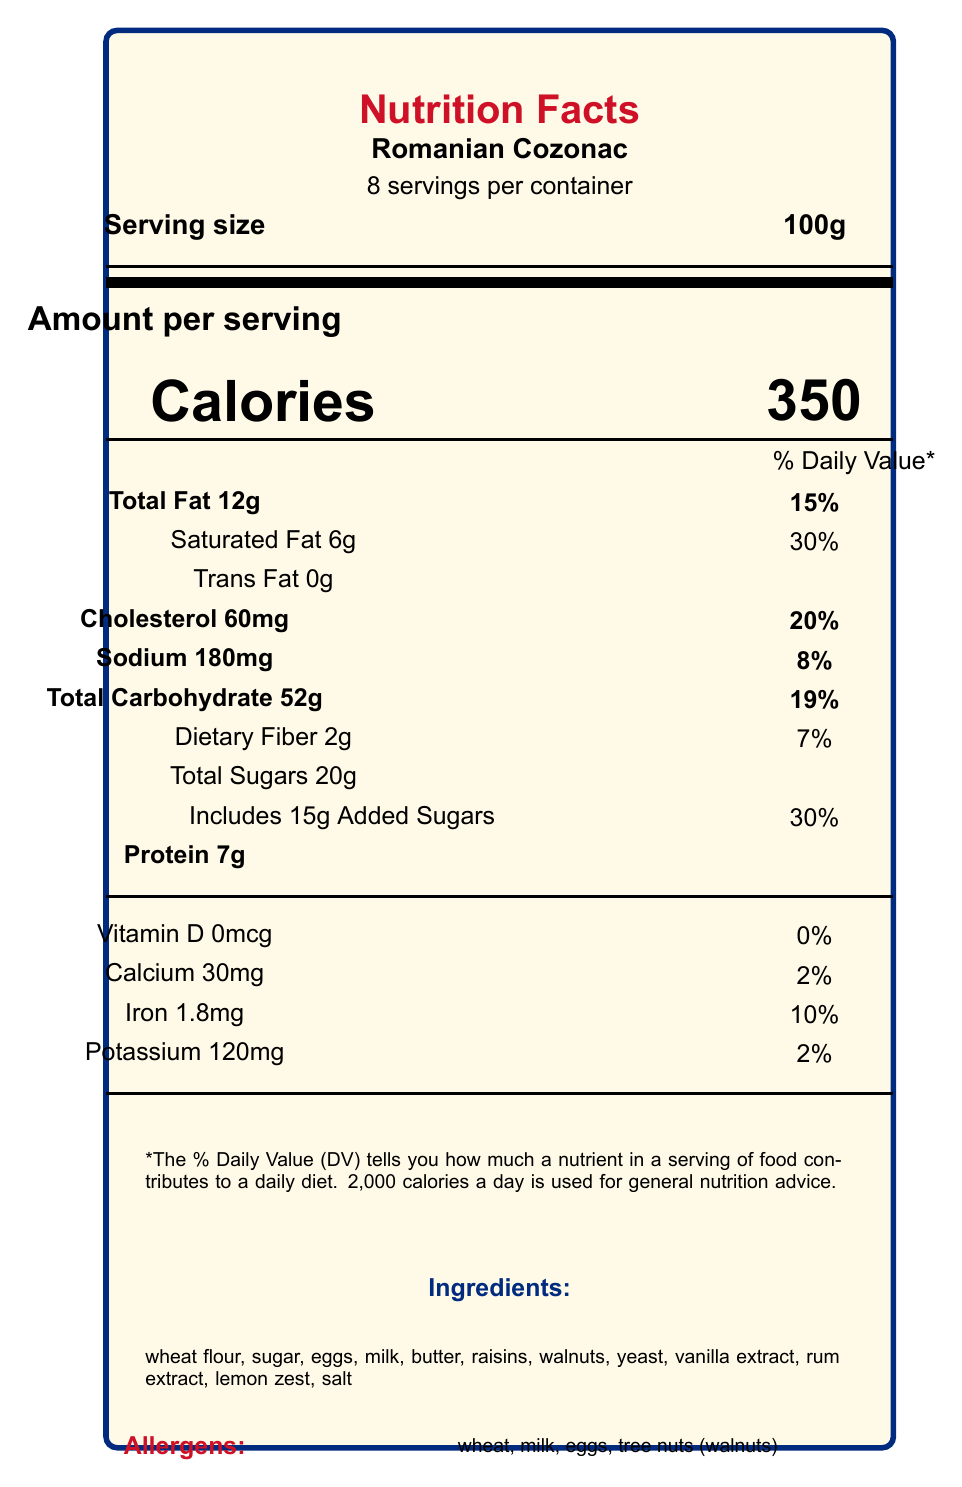what is the serving size for Romanian Cozonac? The document states that the serving size for Romanian Cozonac is 100g.
Answer: 100g how many servings are there per container? It is mentioned in the document that there are 8 servings per container.
Answer: 8 how many calories are there per serving? The document clearly indicates that there are 350 calories per serving.
Answer: 350 what is the total fat content per serving? The total fat content per serving is listed as 12g.
Answer: 12g how much sodium is there per serving? The amount of sodium per serving is given as 180mg.
Answer: 180mg what are the daily values percentage for calcium per serving? A. 10% B. 2% C. 30% The document shows that the daily value percentage for calcium per serving is 2%.
Answer: B what is the percentage daily value for saturated fat per serving? A. 15% B. 8% C. 30% D. 20% The percentage daily value for saturated fat per serving is listed as 30%.
Answer: C does this product contain any trans fat? The trans fat content is listed as 0g, indicating that there is no trans fat in this product.
Answer: no is vitamin D present in the Romanian Cozonac? The document shows that there is 0mcg of vitamin D per serving, which means it is not present in the product.
Answer: no explain the main idea of this nutritional facts label The document is a comprehensive nutrition facts label for Romanian Cozonac. It includes essential nutritional details such as serving size, number of servings per container, calories, macronutrients and micronutrients per serving along with their daily value percentages. It also lists the ingredients and allergens present in the product.
Answer: The document provides detailed information about the nutritional content of Romanian Cozonac per 100g serving. It includes data on calories, macronutrients (fats, carbohydrates, proteins), micronutrients (vitamins and minerals), along with the daily values percentages for these nutrients. Additionally, ingredients and allergen information are also provided. what are the main ingredients in Romanian Cozonac? The ingredients list includes all these items as mentioned in the document.
Answer: wheat flour, sugar, eggs, milk, butter, raisins, walnuts, yeast, vanilla extract, rum extract, lemon zest, salt how much protein does one serving provide? The document states that each serving provides 7g of protein.
Answer: 7g what are the allergens mentioned for this product? The allergens listed in the document include wheat, milk, eggs, and tree nuts (walnuts).
Answer: wheat, milk, eggs, tree nuts (walnuts) what is the percentage daily value of iron per serving? The document indicates that the percentage daily value for iron per serving is 10%.
Answer: 10% how much added sugar is there in one serving? It is mentioned that there are 15g of added sugars per serving.
Answer: 15g how does the document describe the cultural significance of Cozonac? The document notes that Cozonac is a traditional holiday bread, especially enjoyed for Christmas and Easter.
Answer: Traditional holiday bread, especially for Christmas and Easter what is the origin of Cozonac as per the document? The document specifies that the origin of Cozonac is Romania.
Answer: Romania what is the daily value percentage of dietary fiber in one serving? The document lists the daily value percentage of dietary fiber per serving as 7%.
Answer: 7% how many milligrams of potassium does one serving contain? Each serving contains 120mg of potassium as mentioned in the document.
Answer: 120mg what is the Romanian word for "sweet bread"? The document only provides the Romanian name "Cozonac" for the product but does not explicitly translate "sweet bread."
Answer: Cannot be determined 